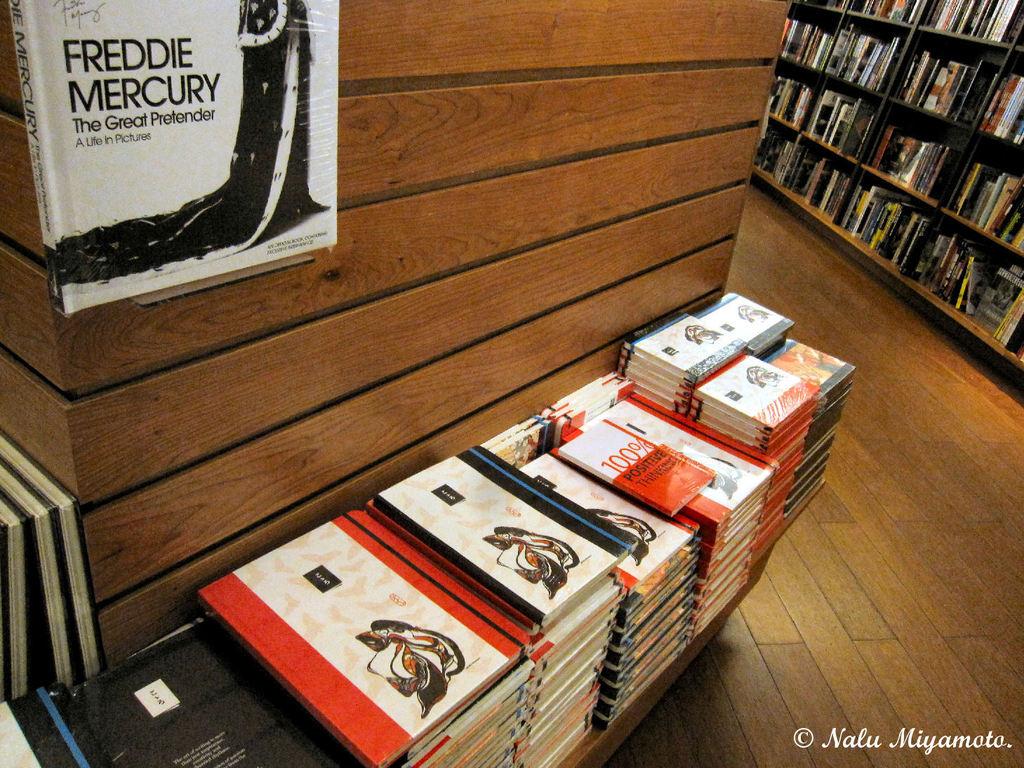Is the book at the top about freddie?
Provide a short and direct response. Yes. What is stacked here on the side?
Provide a short and direct response. Answering does not require reading text in the image. 